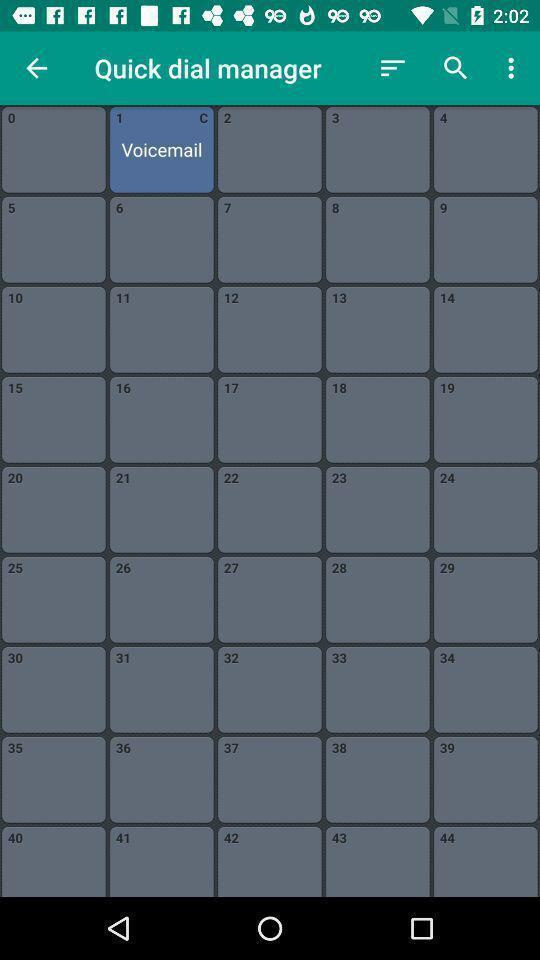Describe the key features of this screenshot. Various quick dials displayed of a calling app. 